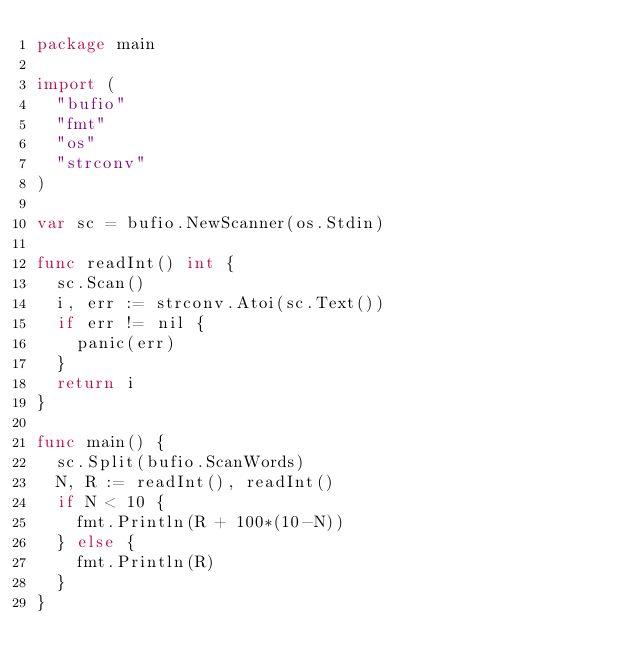Convert code to text. <code><loc_0><loc_0><loc_500><loc_500><_Go_>package main

import (
	"bufio"
	"fmt"
	"os"
	"strconv"
)

var sc = bufio.NewScanner(os.Stdin)

func readInt() int {
	sc.Scan()
	i, err := strconv.Atoi(sc.Text())
	if err != nil {
		panic(err)
	}
	return i
}

func main() {
	sc.Split(bufio.ScanWords)
	N, R := readInt(), readInt()
	if N < 10 {
		fmt.Println(R + 100*(10-N))
	} else {
		fmt.Println(R)
	}
}
</code> 